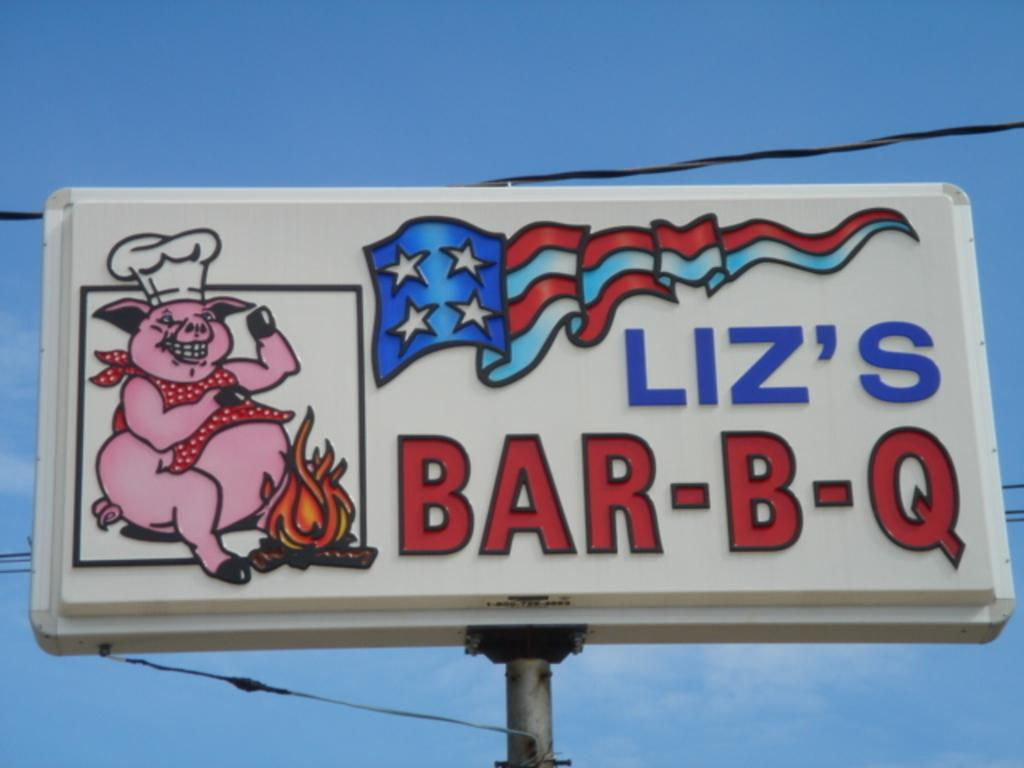Provide a one-sentence caption for the provided image. A billboard sign that shows a pig sitting at a campfire with a chef hat and reads Liz's Bar-B-Q. 